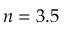Convert formula to latex. <formula><loc_0><loc_0><loc_500><loc_500>n = 3 . 5</formula> 